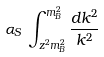Convert formula to latex. <formula><loc_0><loc_0><loc_500><loc_500>\alpha _ { S } \, \int _ { z ^ { 2 } m _ { B } ^ { 2 } } ^ { m _ { B } ^ { 2 } } \frac { d k ^ { 2 } } { k ^ { 2 } }</formula> 